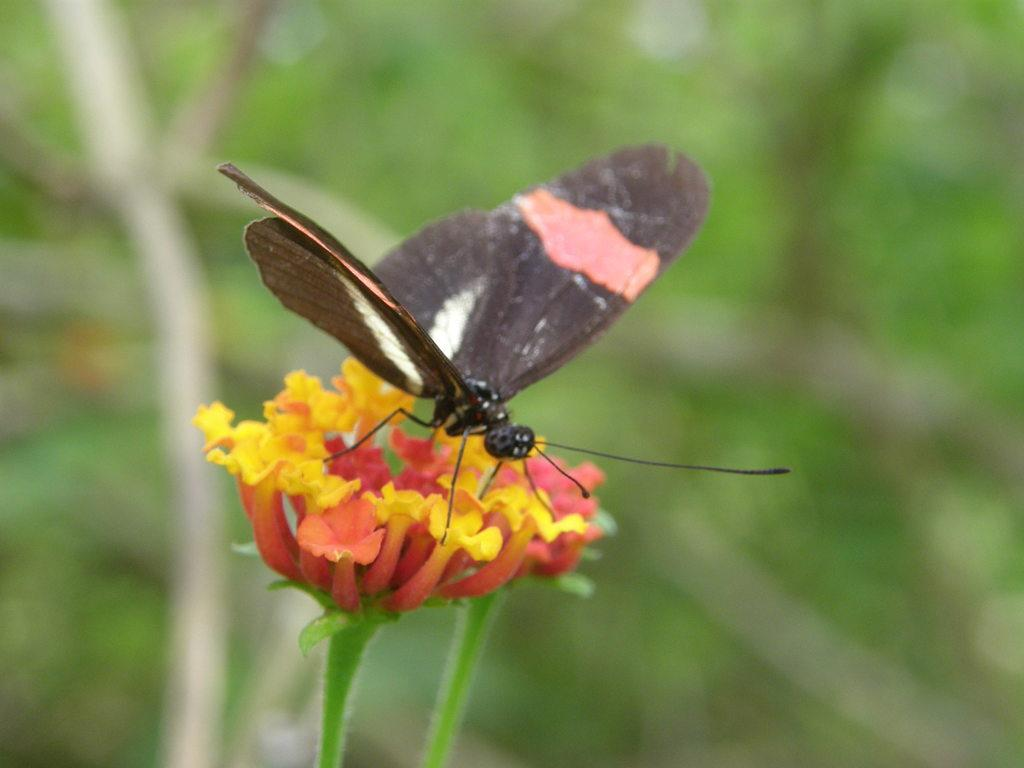How many flowers can be seen in the image? There are two flowers in the image. What other living organism is present in the image? There is a butterfly in the image. Can you describe the background of the image? The background of the image is blurry, and there might be leaves present. What type of button is being used by the army in the image? There is no button or army present in the image; it features two flowers and a butterfly. What type of fruit is hanging from the flowers in the image? There is no fruit present in the image; it only features flowers and a butterfly. 